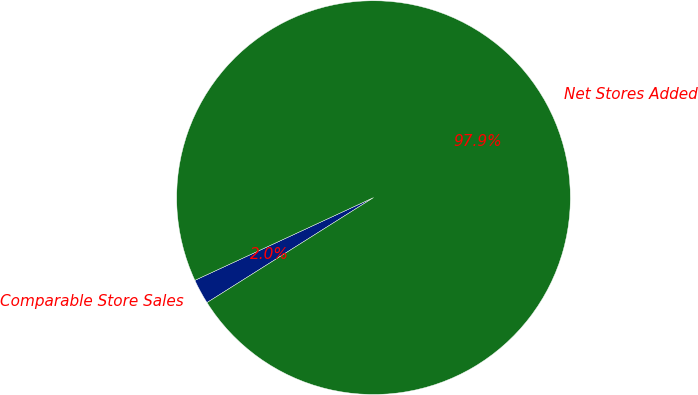Convert chart. <chart><loc_0><loc_0><loc_500><loc_500><pie_chart><fcel>Comparable Store Sales<fcel>Net Stores Added<nl><fcel>2.05%<fcel>97.95%<nl></chart> 